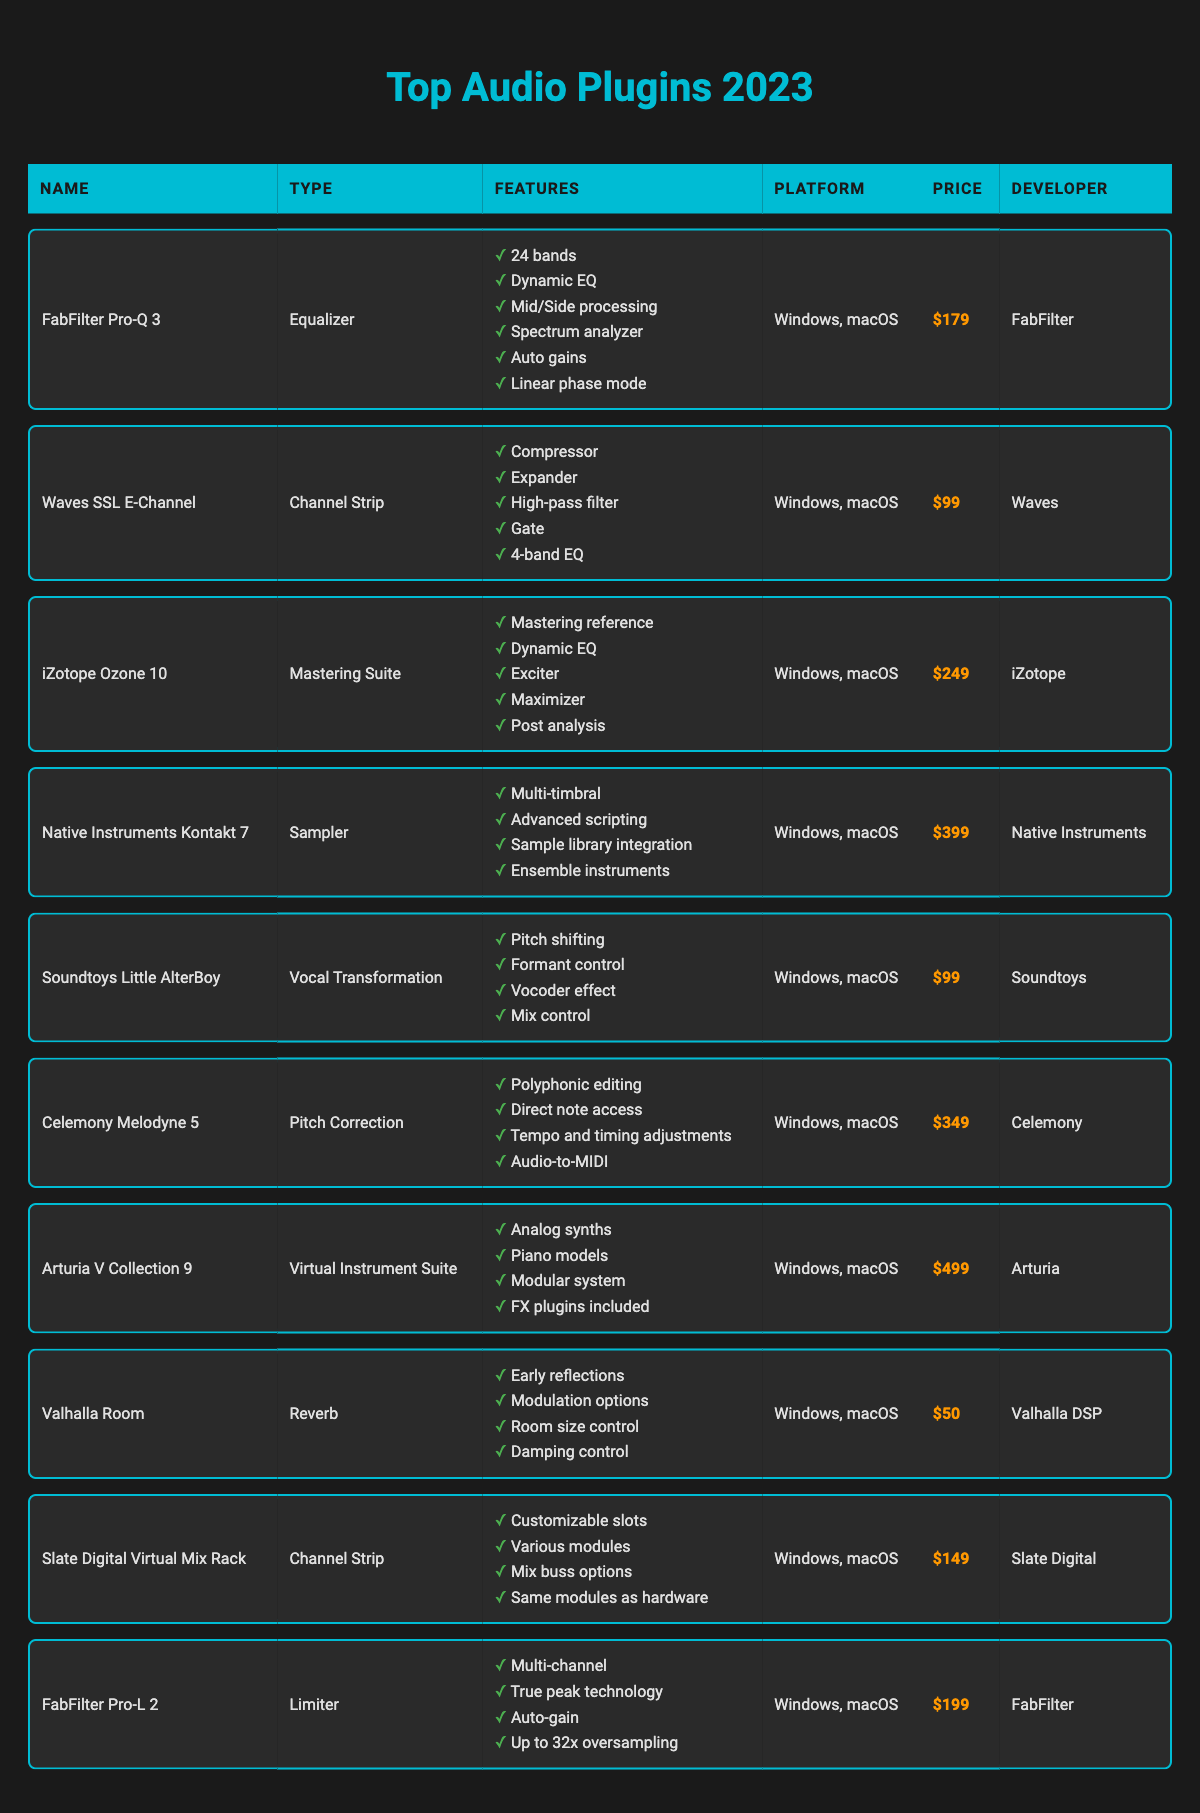What plugins support mid-side processing? By examining the features of each plugin listed in the table, we can see that only the "FabFilter Pro-Q 3" has mid-side processing as a feature.
Answer: FabFilter Pro-Q 3 Which plugin is the most expensive? Looking at the price column, "Arturia V Collection 9" has the highest price at 499, which is more than any other plugin in the table.
Answer: Arturia V Collection 9 Does "Soundtoys Little AlterBoy" include a compressor? Reviewing the features of "Soundtoys Little AlterBoy," it does not list a compressor; the features include pitch shifting, formant control, vocoder effect, and mix control, none of which are a compressor.
Answer: No What is the total price of all the plugins listed? To find the total price, we sum the prices of all plugins: 179 + 99 + 249 + 399 + 99 + 349 + 499 + 50 + 149 + 199 = 1960. Therefore, the total price of all plugins is 1960.
Answer: 1960 Which channels have customizable slots and auto-gain features? By checking the features, "Slate Digital Virtual Mix Rack" has customizable slots, and "FabFilter Pro-L 2" has auto-gain. Therefore, both of them have these features, but they belong to different types.
Answer: Slate Digital Virtual Mix Rack and FabFilter Pro-L 2 Is "Valhalla Room" a mastering suite? Based on the type listed in the table, "Valhalla Room" is categorized as a reverb, not a mastering suite.
Answer: No How many bands does "FabFilter Pro-Q 3" have compared to "iZotope Ozone 10"? "FabFilter Pro-Q 3" has 24 bands as a feature, while "iZotope Ozone 10" does not have a bands feature indicated. For comparison, the bands feature is unique to "FabFilter Pro-Q 3."
Answer: 24 bands What types of audio plugins are available in this table? The table provides the following types of audio plugins: Equalizer, Channel Strip, Mastering Suite, Sampler, Vocal Transformation, Pitch Correction, Virtual Instrument Suite, Reverb, and Limiter, making it a diverse range of audio plugin types.
Answer: 9 types Which developer created the plugin that costs 50? From the price column, "Valhalla Room" is the only plugin that costs 50, and the developer listed for it is Valhalla DSP.
Answer: Valhalla DSP 